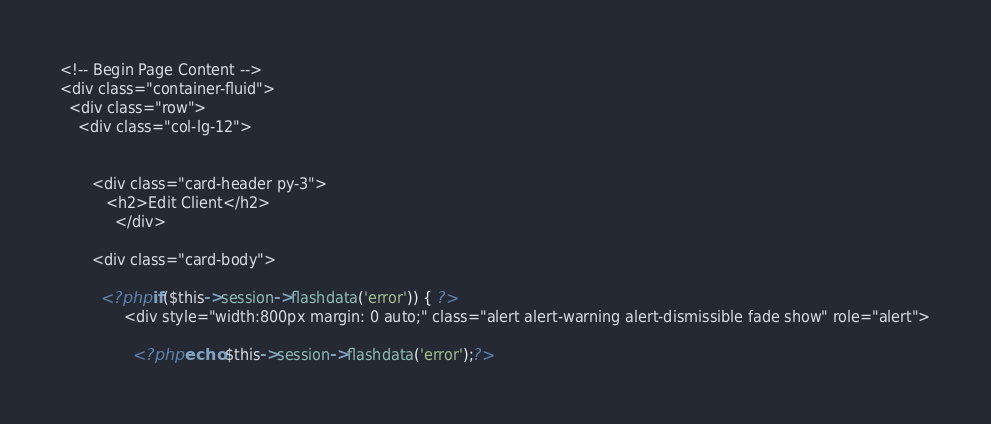<code> <loc_0><loc_0><loc_500><loc_500><_PHP_><!-- Begin Page Content -->
<div class="container-fluid">
  <div class="row">
    <div class="col-lg-12">
      

       <div class="card-header py-3">
          <h2>Edit Client</h2>       
            </div>

       <div class="card-body">

         <?php if($this->session->flashdata('error')) { ?>
              <div style="width:800px margin: 0 auto;" class="alert alert-warning alert-dismissible fade show" role="alert">
                  
                <?php echo $this->session->flashdata('error');?></code> 